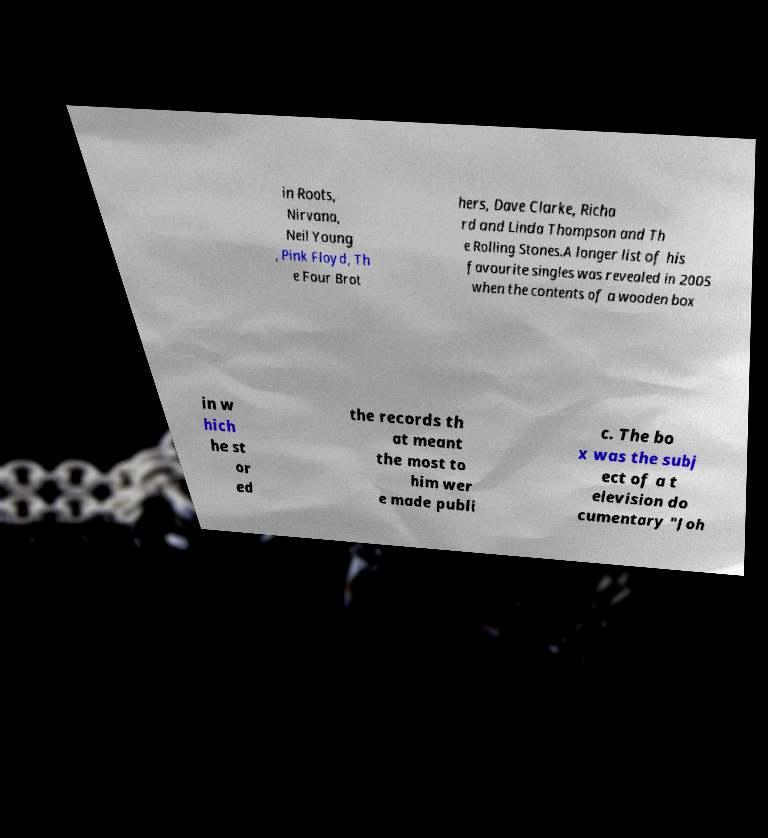Please identify and transcribe the text found in this image. in Roots, Nirvana, Neil Young , Pink Floyd, Th e Four Brot hers, Dave Clarke, Richa rd and Linda Thompson and Th e Rolling Stones.A longer list of his favourite singles was revealed in 2005 when the contents of a wooden box in w hich he st or ed the records th at meant the most to him wer e made publi c. The bo x was the subj ect of a t elevision do cumentary "Joh 